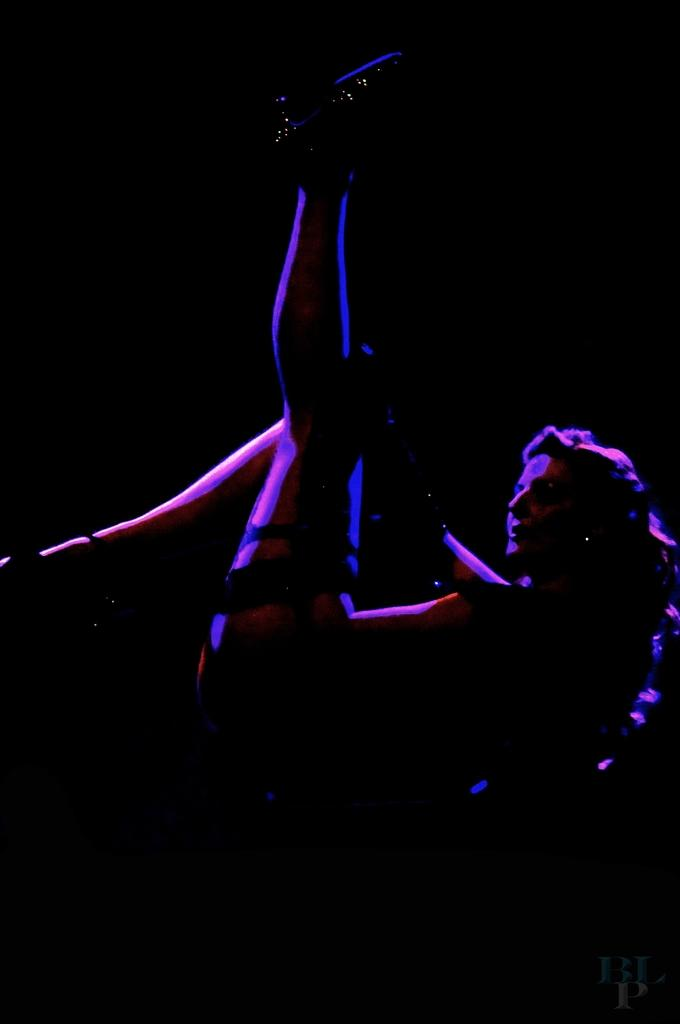What is the position of the woman in the image? The woman is lying down in the image. Can you describe the background of the image? The background of the image appears dark. What type of box is the woman using to play with her team in the image? There is no box or team present in the image; it only features a woman lying down with a dark background. 